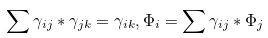<formula> <loc_0><loc_0><loc_500><loc_500>\sum \gamma _ { i j } * \gamma _ { j k } = \gamma _ { i k } , \Phi _ { i } = \sum \gamma _ { i j } * \Phi _ { j }</formula> 